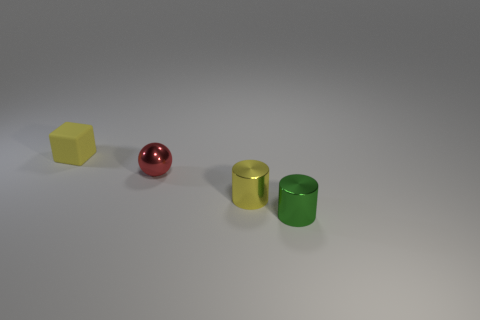There is a object that is the same color as the tiny matte cube; what size is it? small 